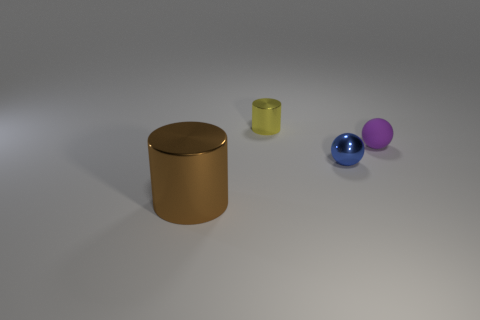Add 2 tiny yellow matte balls. How many objects exist? 6 Add 1 large green matte balls. How many large green matte balls exist? 1 Subtract 0 purple cubes. How many objects are left? 4 Subtract all large brown shiny cylinders. Subtract all tiny yellow cylinders. How many objects are left? 2 Add 2 purple things. How many purple things are left? 3 